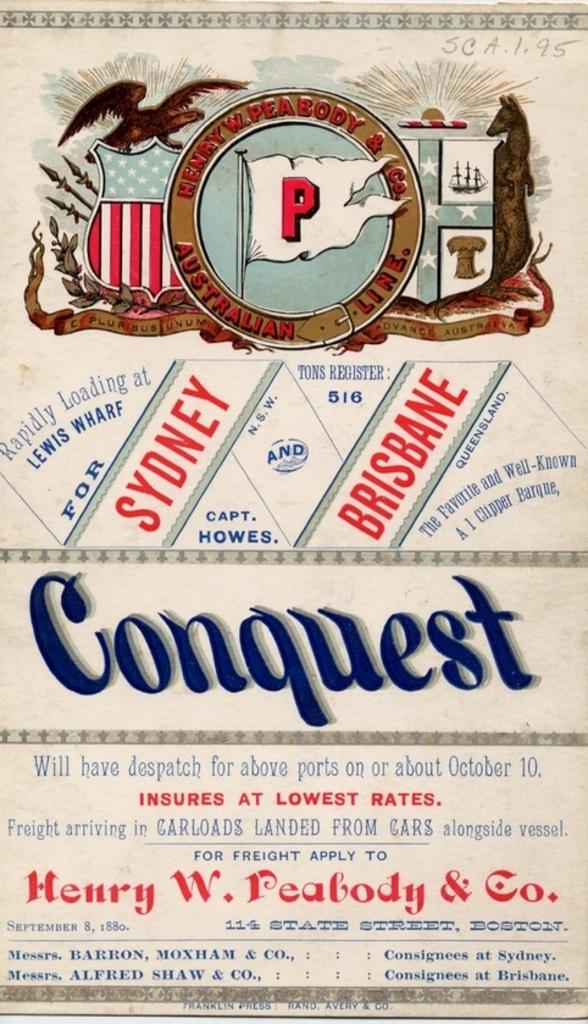<image>
Render a clear and concise summary of the photo. The poster shown contains the Australian towns of Sydney and Brisbane. 